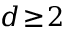Convert formula to latex. <formula><loc_0><loc_0><loc_500><loc_500>d \, \geq \, 2</formula> 